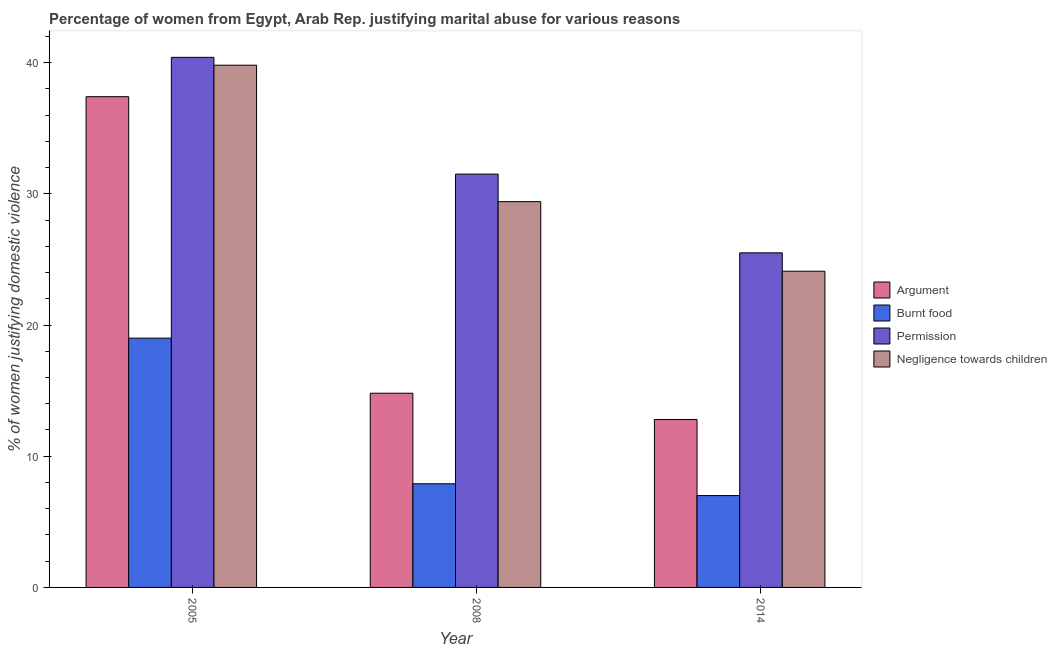How many different coloured bars are there?
Make the answer very short. 4. How many groups of bars are there?
Your response must be concise. 3. Are the number of bars per tick equal to the number of legend labels?
Give a very brief answer. Yes. Are the number of bars on each tick of the X-axis equal?
Offer a terse response. Yes. What is the label of the 1st group of bars from the left?
Make the answer very short. 2005. Across all years, what is the maximum percentage of women justifying abuse in the case of an argument?
Your answer should be very brief. 37.4. What is the total percentage of women justifying abuse for burning food in the graph?
Keep it short and to the point. 33.9. What is the difference between the percentage of women justifying abuse for showing negligence towards children in 2005 and that in 2008?
Your response must be concise. 10.4. What is the difference between the percentage of women justifying abuse for showing negligence towards children in 2014 and the percentage of women justifying abuse for going without permission in 2008?
Provide a short and direct response. -5.3. What is the average percentage of women justifying abuse for showing negligence towards children per year?
Provide a short and direct response. 31.1. What is the ratio of the percentage of women justifying abuse for showing negligence towards children in 2005 to that in 2008?
Offer a very short reply. 1.35. What is the difference between the highest and the second highest percentage of women justifying abuse in the case of an argument?
Offer a terse response. 22.6. What is the difference between the highest and the lowest percentage of women justifying abuse for going without permission?
Keep it short and to the point. 14.9. Is it the case that in every year, the sum of the percentage of women justifying abuse for burning food and percentage of women justifying abuse in the case of an argument is greater than the sum of percentage of women justifying abuse for showing negligence towards children and percentage of women justifying abuse for going without permission?
Your answer should be very brief. No. What does the 2nd bar from the left in 2008 represents?
Offer a terse response. Burnt food. What does the 4th bar from the right in 2014 represents?
Your answer should be compact. Argument. Is it the case that in every year, the sum of the percentage of women justifying abuse in the case of an argument and percentage of women justifying abuse for burning food is greater than the percentage of women justifying abuse for going without permission?
Provide a short and direct response. No. How many years are there in the graph?
Make the answer very short. 3. What is the difference between two consecutive major ticks on the Y-axis?
Make the answer very short. 10. Does the graph contain any zero values?
Ensure brevity in your answer.  No. Where does the legend appear in the graph?
Offer a very short reply. Center right. How many legend labels are there?
Provide a succinct answer. 4. What is the title of the graph?
Your answer should be very brief. Percentage of women from Egypt, Arab Rep. justifying marital abuse for various reasons. Does "Fiscal policy" appear as one of the legend labels in the graph?
Make the answer very short. No. What is the label or title of the X-axis?
Make the answer very short. Year. What is the label or title of the Y-axis?
Keep it short and to the point. % of women justifying domestic violence. What is the % of women justifying domestic violence of Argument in 2005?
Give a very brief answer. 37.4. What is the % of women justifying domestic violence of Permission in 2005?
Your answer should be compact. 40.4. What is the % of women justifying domestic violence in Negligence towards children in 2005?
Offer a very short reply. 39.8. What is the % of women justifying domestic violence in Permission in 2008?
Offer a very short reply. 31.5. What is the % of women justifying domestic violence of Negligence towards children in 2008?
Provide a succinct answer. 29.4. What is the % of women justifying domestic violence of Argument in 2014?
Your answer should be compact. 12.8. What is the % of women justifying domestic violence of Negligence towards children in 2014?
Offer a terse response. 24.1. Across all years, what is the maximum % of women justifying domestic violence in Argument?
Offer a terse response. 37.4. Across all years, what is the maximum % of women justifying domestic violence in Permission?
Make the answer very short. 40.4. Across all years, what is the maximum % of women justifying domestic violence in Negligence towards children?
Offer a terse response. 39.8. Across all years, what is the minimum % of women justifying domestic violence of Burnt food?
Provide a succinct answer. 7. Across all years, what is the minimum % of women justifying domestic violence of Permission?
Your answer should be very brief. 25.5. Across all years, what is the minimum % of women justifying domestic violence of Negligence towards children?
Your response must be concise. 24.1. What is the total % of women justifying domestic violence of Argument in the graph?
Ensure brevity in your answer.  65. What is the total % of women justifying domestic violence of Burnt food in the graph?
Your answer should be compact. 33.9. What is the total % of women justifying domestic violence in Permission in the graph?
Your answer should be very brief. 97.4. What is the total % of women justifying domestic violence of Negligence towards children in the graph?
Ensure brevity in your answer.  93.3. What is the difference between the % of women justifying domestic violence of Argument in 2005 and that in 2008?
Your answer should be very brief. 22.6. What is the difference between the % of women justifying domestic violence of Permission in 2005 and that in 2008?
Offer a very short reply. 8.9. What is the difference between the % of women justifying domestic violence in Negligence towards children in 2005 and that in 2008?
Your answer should be compact. 10.4. What is the difference between the % of women justifying domestic violence in Argument in 2005 and that in 2014?
Offer a very short reply. 24.6. What is the difference between the % of women justifying domestic violence in Negligence towards children in 2005 and that in 2014?
Your answer should be very brief. 15.7. What is the difference between the % of women justifying domestic violence in Argument in 2005 and the % of women justifying domestic violence in Burnt food in 2008?
Your response must be concise. 29.5. What is the difference between the % of women justifying domestic violence in Argument in 2005 and the % of women justifying domestic violence in Negligence towards children in 2008?
Provide a short and direct response. 8. What is the difference between the % of women justifying domestic violence in Argument in 2005 and the % of women justifying domestic violence in Burnt food in 2014?
Give a very brief answer. 30.4. What is the difference between the % of women justifying domestic violence in Argument in 2005 and the % of women justifying domestic violence in Negligence towards children in 2014?
Offer a very short reply. 13.3. What is the difference between the % of women justifying domestic violence in Burnt food in 2005 and the % of women justifying domestic violence in Permission in 2014?
Your answer should be very brief. -6.5. What is the difference between the % of women justifying domestic violence of Burnt food in 2005 and the % of women justifying domestic violence of Negligence towards children in 2014?
Provide a succinct answer. -5.1. What is the difference between the % of women justifying domestic violence of Permission in 2005 and the % of women justifying domestic violence of Negligence towards children in 2014?
Provide a succinct answer. 16.3. What is the difference between the % of women justifying domestic violence of Burnt food in 2008 and the % of women justifying domestic violence of Permission in 2014?
Keep it short and to the point. -17.6. What is the difference between the % of women justifying domestic violence in Burnt food in 2008 and the % of women justifying domestic violence in Negligence towards children in 2014?
Your answer should be compact. -16.2. What is the difference between the % of women justifying domestic violence in Permission in 2008 and the % of women justifying domestic violence in Negligence towards children in 2014?
Provide a short and direct response. 7.4. What is the average % of women justifying domestic violence in Argument per year?
Ensure brevity in your answer.  21.67. What is the average % of women justifying domestic violence of Burnt food per year?
Offer a terse response. 11.3. What is the average % of women justifying domestic violence in Permission per year?
Provide a succinct answer. 32.47. What is the average % of women justifying domestic violence in Negligence towards children per year?
Your response must be concise. 31.1. In the year 2005, what is the difference between the % of women justifying domestic violence in Argument and % of women justifying domestic violence in Permission?
Offer a terse response. -3. In the year 2005, what is the difference between the % of women justifying domestic violence in Argument and % of women justifying domestic violence in Negligence towards children?
Give a very brief answer. -2.4. In the year 2005, what is the difference between the % of women justifying domestic violence in Burnt food and % of women justifying domestic violence in Permission?
Offer a very short reply. -21.4. In the year 2005, what is the difference between the % of women justifying domestic violence in Burnt food and % of women justifying domestic violence in Negligence towards children?
Your answer should be compact. -20.8. In the year 2005, what is the difference between the % of women justifying domestic violence in Permission and % of women justifying domestic violence in Negligence towards children?
Your answer should be compact. 0.6. In the year 2008, what is the difference between the % of women justifying domestic violence of Argument and % of women justifying domestic violence of Permission?
Your answer should be very brief. -16.7. In the year 2008, what is the difference between the % of women justifying domestic violence of Argument and % of women justifying domestic violence of Negligence towards children?
Offer a terse response. -14.6. In the year 2008, what is the difference between the % of women justifying domestic violence in Burnt food and % of women justifying domestic violence in Permission?
Your answer should be compact. -23.6. In the year 2008, what is the difference between the % of women justifying domestic violence of Burnt food and % of women justifying domestic violence of Negligence towards children?
Your answer should be compact. -21.5. In the year 2008, what is the difference between the % of women justifying domestic violence in Permission and % of women justifying domestic violence in Negligence towards children?
Provide a short and direct response. 2.1. In the year 2014, what is the difference between the % of women justifying domestic violence in Argument and % of women justifying domestic violence in Burnt food?
Ensure brevity in your answer.  5.8. In the year 2014, what is the difference between the % of women justifying domestic violence of Argument and % of women justifying domestic violence of Permission?
Provide a succinct answer. -12.7. In the year 2014, what is the difference between the % of women justifying domestic violence in Argument and % of women justifying domestic violence in Negligence towards children?
Your response must be concise. -11.3. In the year 2014, what is the difference between the % of women justifying domestic violence in Burnt food and % of women justifying domestic violence in Permission?
Keep it short and to the point. -18.5. In the year 2014, what is the difference between the % of women justifying domestic violence of Burnt food and % of women justifying domestic violence of Negligence towards children?
Provide a short and direct response. -17.1. What is the ratio of the % of women justifying domestic violence in Argument in 2005 to that in 2008?
Your answer should be compact. 2.53. What is the ratio of the % of women justifying domestic violence in Burnt food in 2005 to that in 2008?
Make the answer very short. 2.41. What is the ratio of the % of women justifying domestic violence of Permission in 2005 to that in 2008?
Offer a very short reply. 1.28. What is the ratio of the % of women justifying domestic violence of Negligence towards children in 2005 to that in 2008?
Offer a terse response. 1.35. What is the ratio of the % of women justifying domestic violence in Argument in 2005 to that in 2014?
Offer a very short reply. 2.92. What is the ratio of the % of women justifying domestic violence in Burnt food in 2005 to that in 2014?
Your answer should be compact. 2.71. What is the ratio of the % of women justifying domestic violence in Permission in 2005 to that in 2014?
Make the answer very short. 1.58. What is the ratio of the % of women justifying domestic violence of Negligence towards children in 2005 to that in 2014?
Offer a very short reply. 1.65. What is the ratio of the % of women justifying domestic violence in Argument in 2008 to that in 2014?
Your response must be concise. 1.16. What is the ratio of the % of women justifying domestic violence in Burnt food in 2008 to that in 2014?
Offer a terse response. 1.13. What is the ratio of the % of women justifying domestic violence in Permission in 2008 to that in 2014?
Offer a very short reply. 1.24. What is the ratio of the % of women justifying domestic violence in Negligence towards children in 2008 to that in 2014?
Give a very brief answer. 1.22. What is the difference between the highest and the second highest % of women justifying domestic violence of Argument?
Make the answer very short. 22.6. What is the difference between the highest and the second highest % of women justifying domestic violence in Permission?
Provide a short and direct response. 8.9. What is the difference between the highest and the lowest % of women justifying domestic violence in Argument?
Make the answer very short. 24.6. 